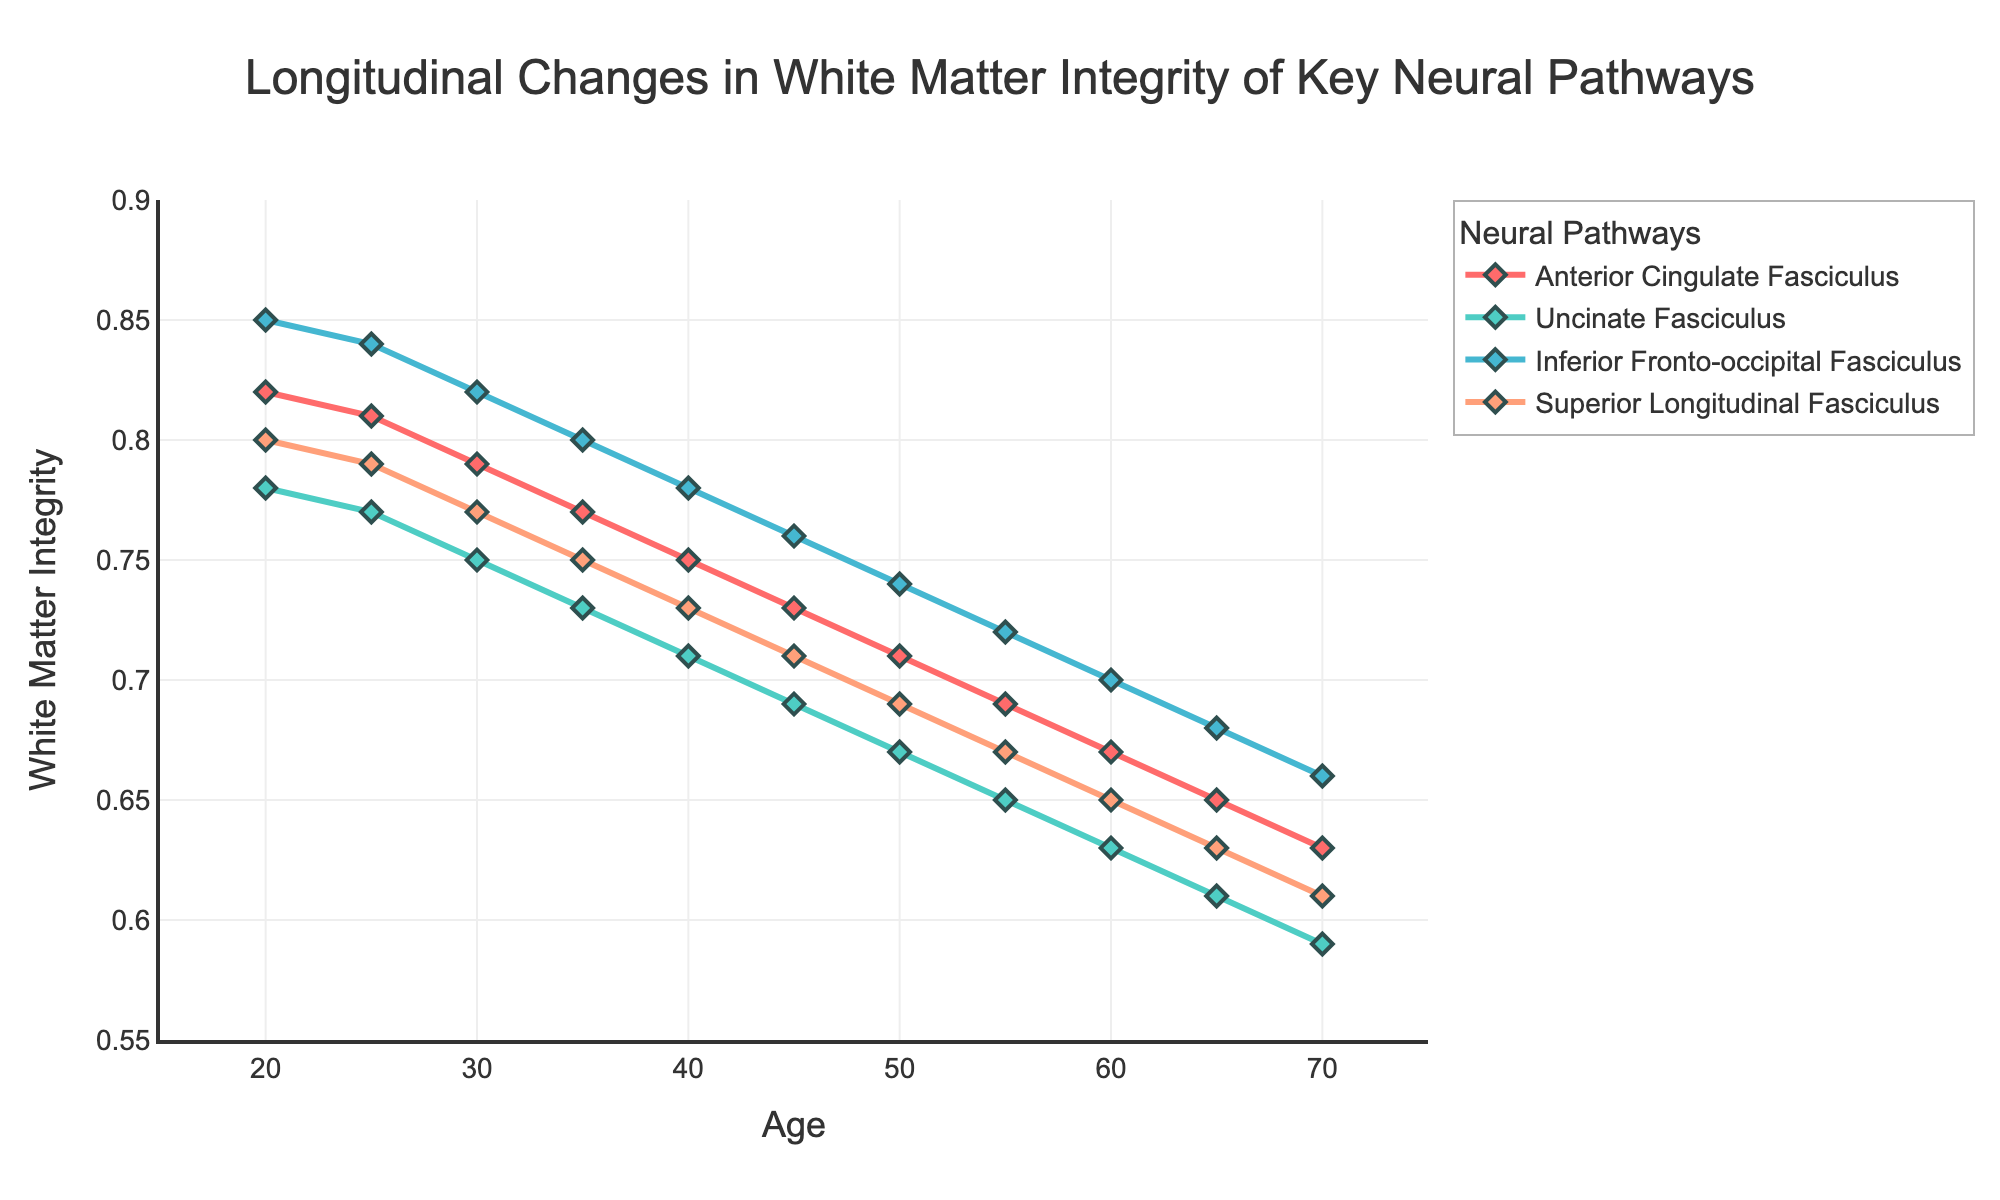Which neural pathway has the highest white matter integrity at age 25? Look at the data points on the chart for age 25 and compare the values of the four neural pathways.
Answer: Inferior Fronto-occipital Fasciculus Which neural pathway shows the steepest decline in white matter integrity from age 20 to age 70? Identify the pathway with the largest decrease in value from age 20 to age 70 using the visual slopes of the lines. The Anterior Cingulate Fasciculus has the steepest negative slope.
Answer: Anterior Cingulate Fasciculus At what age does the white matter integrity of the Anterior Cingulate Fasciculus first drop below 0.75? Look at the points on the Anterior Cingulate Fasciculus line and find where it drops below 0.75.
Answer: Age 35 How much does the white matter integrity of the Superior Longitudinal Fasciculus change between age 30 and age 50? Compare the values of the Superior Longitudinal Fasciculus at age 30 and age 50, then subtract the value at age 50 from the one at age 30.
Answer: 0.08 (0.77 - 0.69) Which two neural pathways have values that are closest at age 60? Compare the data points for all pathways at age 60 and find the smallest difference between two values.
Answer: Uncinate Fasciculus and Superior Longitudinal Fasciculus What is the average white matter integrity of the Inferior Fronto-occipital Fasciculus from age 20 to 70? Add the values of the Inferior Fronto-occipital Fasciculus from all ages and divide by the number of ages (11).
Answer: 0.766 (8.43 / 11) How does the white matter integrity of the Uncinate Fasciculus change on average per decade? Calculate the total change in the Uncinate Fasciculus from age 20 to age 70 and divide by the number of decades (5).
Answer: -0.038 ((0.78 - 0.59) / 5) 